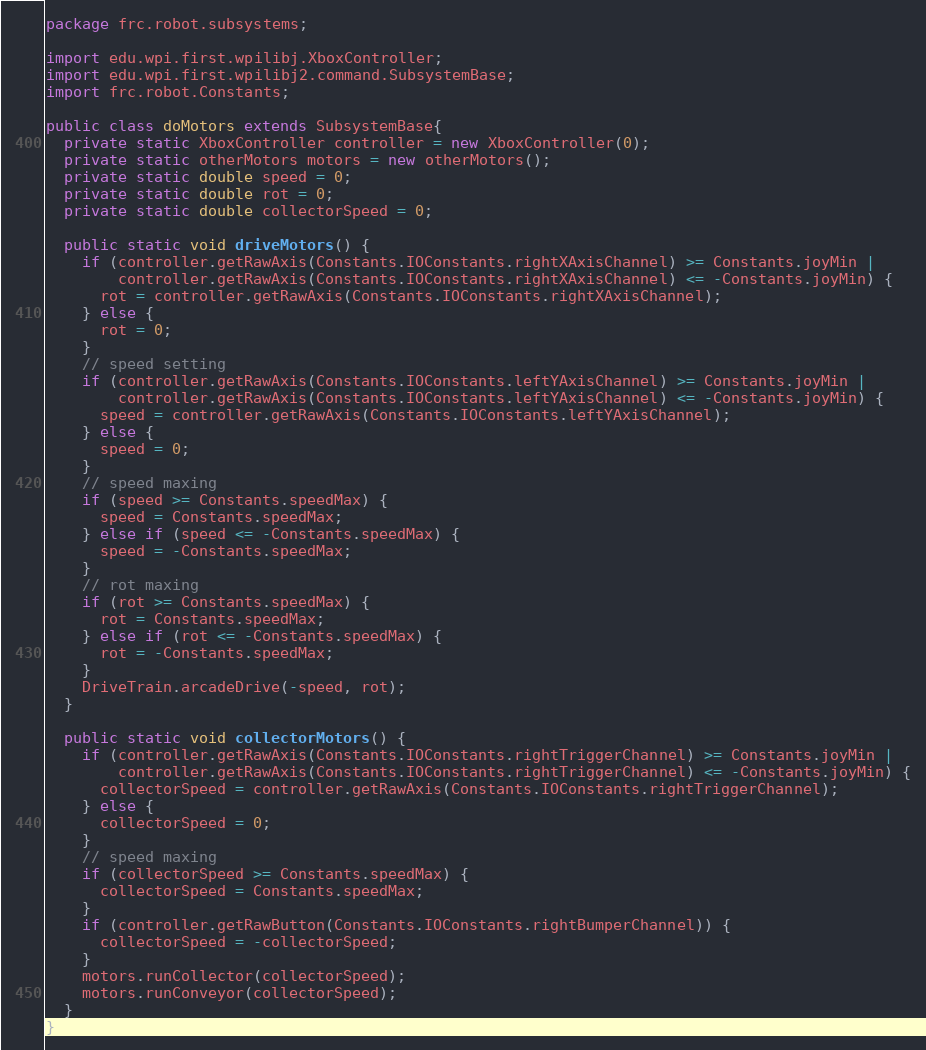<code> <loc_0><loc_0><loc_500><loc_500><_Java_>package frc.robot.subsystems;

import edu.wpi.first.wpilibj.XboxController;
import edu.wpi.first.wpilibj2.command.SubsystemBase;
import frc.robot.Constants;

public class doMotors extends SubsystemBase{
  private static XboxController controller = new XboxController(0);
  private static otherMotors motors = new otherMotors();
  private static double speed = 0;
  private static double rot = 0;
  private static double collectorSpeed = 0;

  public static void driveMotors() {
    if (controller.getRawAxis(Constants.IOConstants.rightXAxisChannel) >= Constants.joyMin |
        controller.getRawAxis(Constants.IOConstants.rightXAxisChannel) <= -Constants.joyMin) {
      rot = controller.getRawAxis(Constants.IOConstants.rightXAxisChannel);
    } else {
      rot = 0;
    }
    // speed setting
    if (controller.getRawAxis(Constants.IOConstants.leftYAxisChannel) >= Constants.joyMin |
        controller.getRawAxis(Constants.IOConstants.leftYAxisChannel) <= -Constants.joyMin) {
      speed = controller.getRawAxis(Constants.IOConstants.leftYAxisChannel);
    } else {
      speed = 0;
    }
    // speed maxing
    if (speed >= Constants.speedMax) {
      speed = Constants.speedMax;
    } else if (speed <= -Constants.speedMax) {
      speed = -Constants.speedMax;
    }
    // rot maxing
    if (rot >= Constants.speedMax) {
      rot = Constants.speedMax;
    } else if (rot <= -Constants.speedMax) {
      rot = -Constants.speedMax;
    }
    DriveTrain.arcadeDrive(-speed, rot);
  }

  public static void collectorMotors() {
    if (controller.getRawAxis(Constants.IOConstants.rightTriggerChannel) >= Constants.joyMin |
        controller.getRawAxis(Constants.IOConstants.rightTriggerChannel) <= -Constants.joyMin) {
      collectorSpeed = controller.getRawAxis(Constants.IOConstants.rightTriggerChannel);
    } else {
      collectorSpeed = 0;
    }
    // speed maxing
    if (collectorSpeed >= Constants.speedMax) {
      collectorSpeed = Constants.speedMax;
    }
    if (controller.getRawButton(Constants.IOConstants.rightBumperChannel)) {
      collectorSpeed = -collectorSpeed;
    }
    motors.runCollector(collectorSpeed);
    motors.runConveyor(collectorSpeed);
  }
}
</code> 